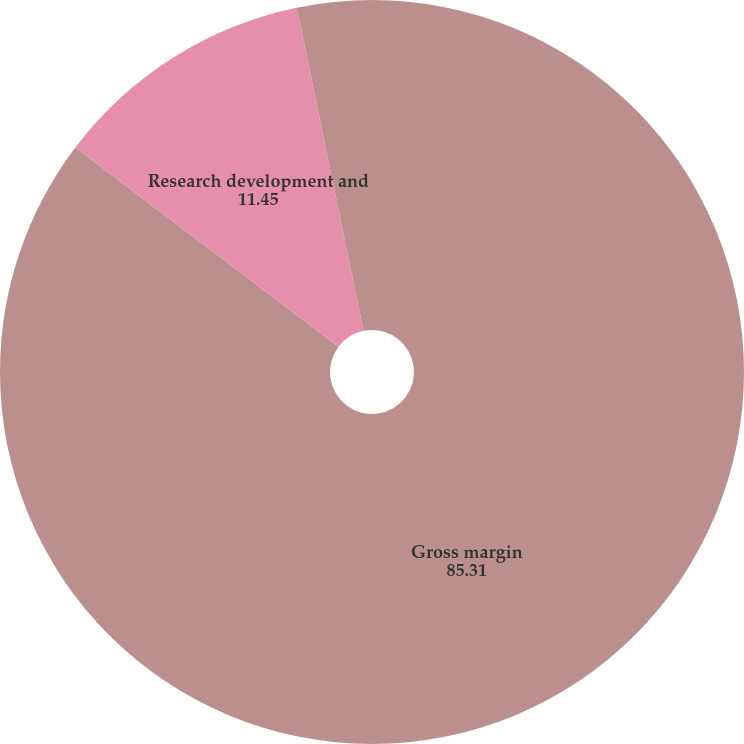<chart> <loc_0><loc_0><loc_500><loc_500><pie_chart><fcel>Gross margin<fcel>Research development and<fcel>Equity royalty and interest<nl><fcel>85.31%<fcel>11.45%<fcel>3.24%<nl></chart> 